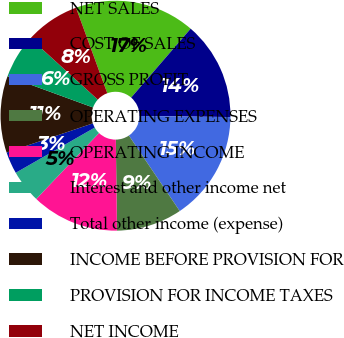<chart> <loc_0><loc_0><loc_500><loc_500><pie_chart><fcel>NET SALES<fcel>COST OF SALES<fcel>GROSS PROFIT<fcel>OPERATING EXPENSES<fcel>OPERATING INCOME<fcel>Interest and other income net<fcel>Total other income (expense)<fcel>INCOME BEFORE PROVISION FOR<fcel>PROVISION FOR INCOME TAXES<fcel>NET INCOME<nl><fcel>16.92%<fcel>13.85%<fcel>15.38%<fcel>9.23%<fcel>12.31%<fcel>4.62%<fcel>3.08%<fcel>10.77%<fcel>6.15%<fcel>7.69%<nl></chart> 